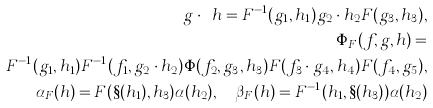<formula> <loc_0><loc_0><loc_500><loc_500>g \cdot _ { _ { F } } h = F ^ { - 1 } ( g _ { 1 } , h _ { 1 } ) g _ { 2 } \cdot h _ { 2 } F ( g _ { 3 } , h _ { 3 } ) , \\ \Phi _ { F } ( f , g , h ) = \\ F ^ { - 1 } ( g _ { 1 } , h _ { 1 } ) F ^ { - 1 } ( f _ { 1 } , g _ { 2 } \cdot h _ { 2 } ) \Phi ( f _ { 2 } , g _ { 3 } , h _ { 3 } ) F ( f _ { 3 } \cdot g _ { 4 } , h _ { 4 } ) F ( f _ { 4 } , g _ { 5 } ) , \\ \alpha _ { F } ( h ) = F ( \S ( h _ { 1 } ) , h _ { 3 } ) \alpha ( h _ { 2 } ) , \quad \beta _ { F } ( h ) = F ^ { - 1 } ( h _ { 1 } , \S ( h _ { 3 } ) ) \alpha ( h _ { 2 } )</formula> 